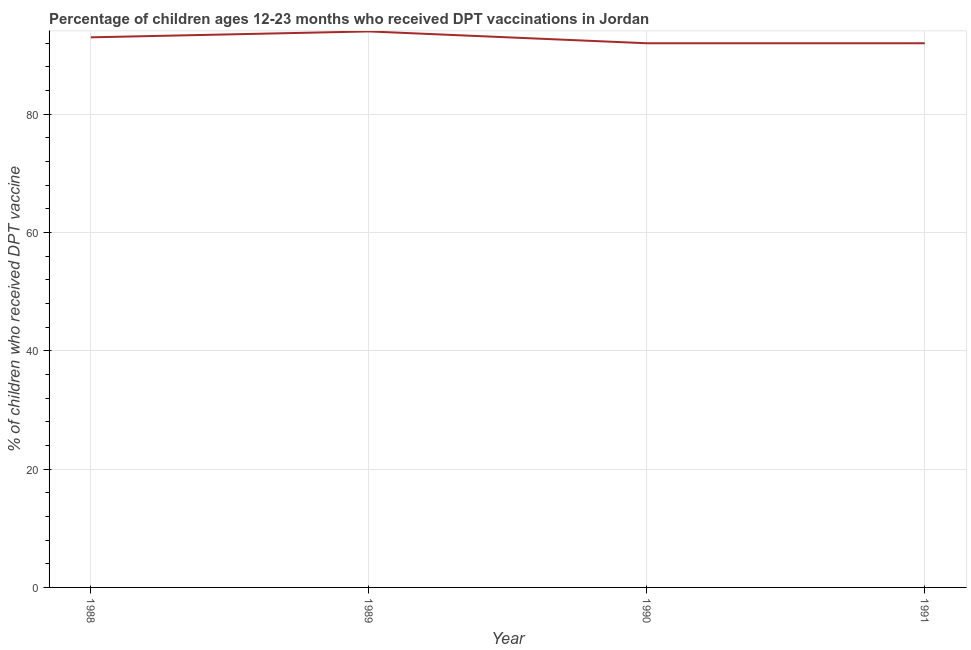What is the percentage of children who received dpt vaccine in 1991?
Provide a succinct answer. 92. Across all years, what is the maximum percentage of children who received dpt vaccine?
Offer a very short reply. 94. Across all years, what is the minimum percentage of children who received dpt vaccine?
Keep it short and to the point. 92. In which year was the percentage of children who received dpt vaccine maximum?
Offer a terse response. 1989. What is the sum of the percentage of children who received dpt vaccine?
Make the answer very short. 371. What is the difference between the percentage of children who received dpt vaccine in 1988 and 1991?
Make the answer very short. 1. What is the average percentage of children who received dpt vaccine per year?
Offer a terse response. 92.75. What is the median percentage of children who received dpt vaccine?
Provide a short and direct response. 92.5. What is the ratio of the percentage of children who received dpt vaccine in 1988 to that in 1991?
Provide a succinct answer. 1.01. What is the difference between the highest and the lowest percentage of children who received dpt vaccine?
Your answer should be compact. 2. In how many years, is the percentage of children who received dpt vaccine greater than the average percentage of children who received dpt vaccine taken over all years?
Make the answer very short. 2. Does the percentage of children who received dpt vaccine monotonically increase over the years?
Make the answer very short. No. How many years are there in the graph?
Your answer should be very brief. 4. What is the difference between two consecutive major ticks on the Y-axis?
Offer a terse response. 20. Are the values on the major ticks of Y-axis written in scientific E-notation?
Provide a short and direct response. No. Does the graph contain any zero values?
Ensure brevity in your answer.  No. Does the graph contain grids?
Provide a short and direct response. Yes. What is the title of the graph?
Your answer should be very brief. Percentage of children ages 12-23 months who received DPT vaccinations in Jordan. What is the label or title of the X-axis?
Keep it short and to the point. Year. What is the label or title of the Y-axis?
Your response must be concise. % of children who received DPT vaccine. What is the % of children who received DPT vaccine in 1988?
Give a very brief answer. 93. What is the % of children who received DPT vaccine in 1989?
Your answer should be compact. 94. What is the % of children who received DPT vaccine in 1990?
Your answer should be compact. 92. What is the % of children who received DPT vaccine in 1991?
Ensure brevity in your answer.  92. What is the difference between the % of children who received DPT vaccine in 1988 and 1989?
Offer a very short reply. -1. What is the difference between the % of children who received DPT vaccine in 1988 and 1990?
Ensure brevity in your answer.  1. What is the difference between the % of children who received DPT vaccine in 1989 and 1990?
Ensure brevity in your answer.  2. What is the difference between the % of children who received DPT vaccine in 1989 and 1991?
Give a very brief answer. 2. What is the ratio of the % of children who received DPT vaccine in 1988 to that in 1989?
Keep it short and to the point. 0.99. What is the ratio of the % of children who received DPT vaccine in 1988 to that in 1991?
Your response must be concise. 1.01. 